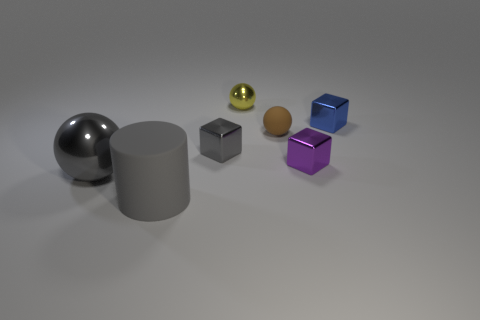Does the shiny thing that is behind the blue object have the same size as the tiny blue metal block?
Your response must be concise. Yes. Is the number of purple metallic blocks that are in front of the tiny gray cube less than the number of objects that are right of the big matte cylinder?
Give a very brief answer. Yes. Do the large rubber thing and the large shiny ball have the same color?
Your answer should be compact. Yes. Are there fewer small purple blocks that are behind the small blue metal cube than big gray balls?
Ensure brevity in your answer.  Yes. There is a block that is the same color as the cylinder; what is it made of?
Your answer should be very brief. Metal. Do the small gray block and the tiny blue object have the same material?
Keep it short and to the point. Yes. How many brown cubes have the same material as the brown ball?
Offer a very short reply. 0. What is the color of the thing that is the same material as the big gray cylinder?
Make the answer very short. Brown. What shape is the small gray metallic object?
Keep it short and to the point. Cube. What is the large gray object that is to the right of the large gray metallic ball made of?
Your answer should be very brief. Rubber. 